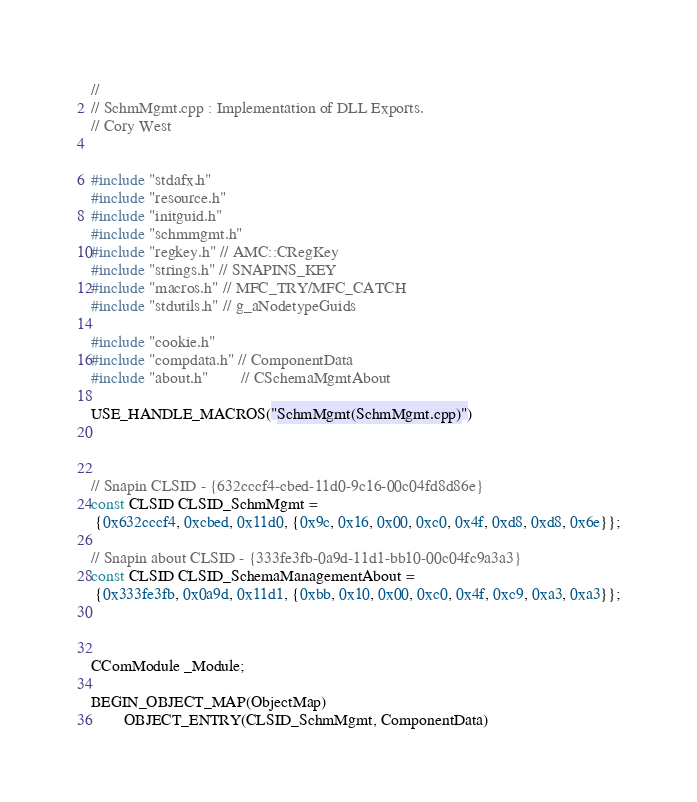<code> <loc_0><loc_0><loc_500><loc_500><_C++_>//
// SchmMgmt.cpp : Implementation of DLL Exports.
// Cory West


#include "stdafx.h"
#include "resource.h"
#include "initguid.h"
#include "schmmgmt.h"
#include "regkey.h" // AMC::CRegKey
#include "strings.h" // SNAPINS_KEY
#include "macros.h" // MFC_TRY/MFC_CATCH
#include "stdutils.h" // g_aNodetypeGuids

#include "cookie.h"
#include "compdata.h" // ComponentData
#include "about.h"        // CSchemaMgmtAbout

USE_HANDLE_MACROS("SchmMgmt(SchmMgmt.cpp)")



// Snapin CLSID - {632cccf4-cbed-11d0-9c16-00c04fd8d86e}
const CLSID CLSID_SchmMgmt =
 {0x632cccf4, 0xcbed, 0x11d0, {0x9c, 0x16, 0x00, 0xc0, 0x4f, 0xd8, 0xd8, 0x6e}};

// Snapin about CLSID - {333fe3fb-0a9d-11d1-bb10-00c04fc9a3a3}
const CLSID CLSID_SchemaManagementAbout =
 {0x333fe3fb, 0x0a9d, 0x11d1, {0xbb, 0x10, 0x00, 0xc0, 0x4f, 0xc9, 0xa3, 0xa3}};



CComModule _Module;

BEGIN_OBJECT_MAP(ObjectMap)
        OBJECT_ENTRY(CLSID_SchmMgmt, ComponentData)</code> 